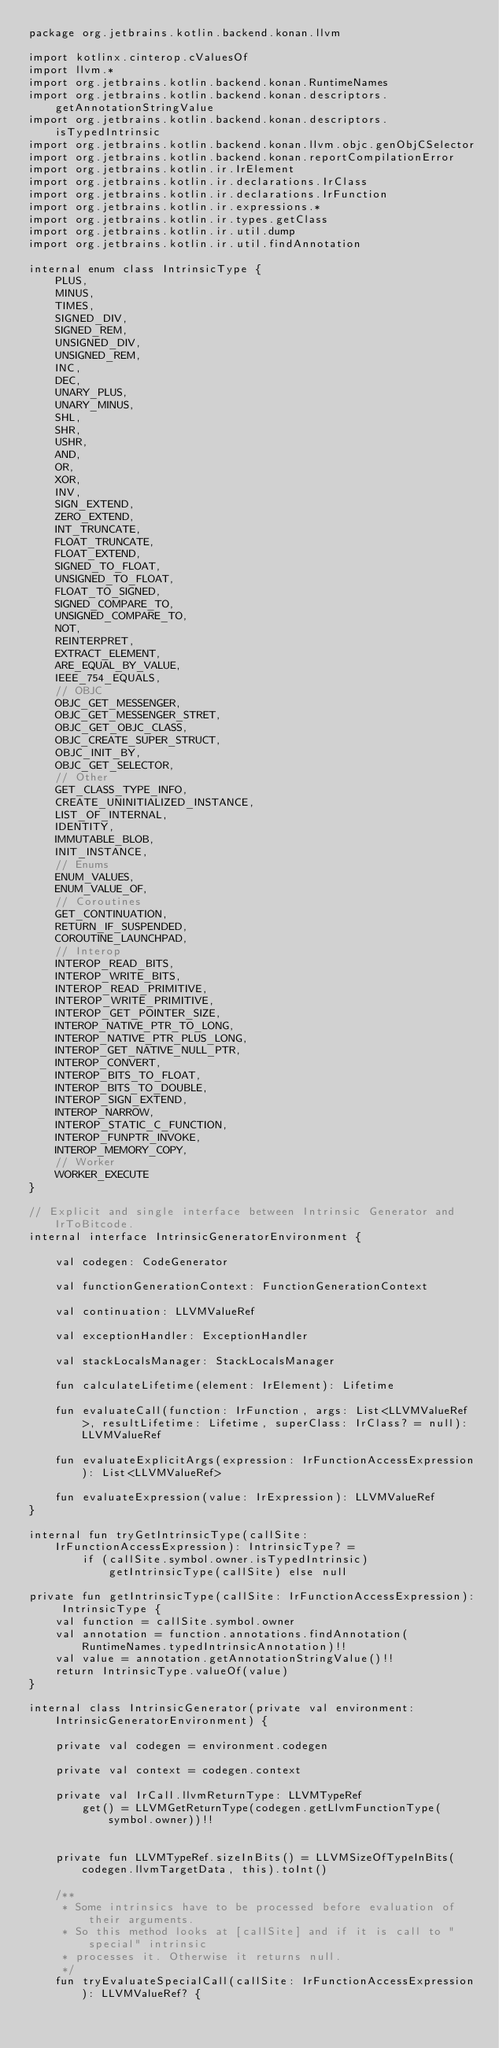Convert code to text. <code><loc_0><loc_0><loc_500><loc_500><_Kotlin_>package org.jetbrains.kotlin.backend.konan.llvm

import kotlinx.cinterop.cValuesOf
import llvm.*
import org.jetbrains.kotlin.backend.konan.RuntimeNames
import org.jetbrains.kotlin.backend.konan.descriptors.getAnnotationStringValue
import org.jetbrains.kotlin.backend.konan.descriptors.isTypedIntrinsic
import org.jetbrains.kotlin.backend.konan.llvm.objc.genObjCSelector
import org.jetbrains.kotlin.backend.konan.reportCompilationError
import org.jetbrains.kotlin.ir.IrElement
import org.jetbrains.kotlin.ir.declarations.IrClass
import org.jetbrains.kotlin.ir.declarations.IrFunction
import org.jetbrains.kotlin.ir.expressions.*
import org.jetbrains.kotlin.ir.types.getClass
import org.jetbrains.kotlin.ir.util.dump
import org.jetbrains.kotlin.ir.util.findAnnotation

internal enum class IntrinsicType {
    PLUS,
    MINUS,
    TIMES,
    SIGNED_DIV,
    SIGNED_REM,
    UNSIGNED_DIV,
    UNSIGNED_REM,
    INC,
    DEC,
    UNARY_PLUS,
    UNARY_MINUS,
    SHL,
    SHR,
    USHR,
    AND,
    OR,
    XOR,
    INV,
    SIGN_EXTEND,
    ZERO_EXTEND,
    INT_TRUNCATE,
    FLOAT_TRUNCATE,
    FLOAT_EXTEND,
    SIGNED_TO_FLOAT,
    UNSIGNED_TO_FLOAT,
    FLOAT_TO_SIGNED,
    SIGNED_COMPARE_TO,
    UNSIGNED_COMPARE_TO,
    NOT,
    REINTERPRET,
    EXTRACT_ELEMENT,
    ARE_EQUAL_BY_VALUE,
    IEEE_754_EQUALS,
    // OBJC
    OBJC_GET_MESSENGER,
    OBJC_GET_MESSENGER_STRET,
    OBJC_GET_OBJC_CLASS,
    OBJC_CREATE_SUPER_STRUCT,
    OBJC_INIT_BY,
    OBJC_GET_SELECTOR,
    // Other
    GET_CLASS_TYPE_INFO,
    CREATE_UNINITIALIZED_INSTANCE,
    LIST_OF_INTERNAL,
    IDENTITY,
    IMMUTABLE_BLOB,
    INIT_INSTANCE,
    // Enums
    ENUM_VALUES,
    ENUM_VALUE_OF,
    // Coroutines
    GET_CONTINUATION,
    RETURN_IF_SUSPENDED,
    COROUTINE_LAUNCHPAD,
    // Interop
    INTEROP_READ_BITS,
    INTEROP_WRITE_BITS,
    INTEROP_READ_PRIMITIVE,
    INTEROP_WRITE_PRIMITIVE,
    INTEROP_GET_POINTER_SIZE,
    INTEROP_NATIVE_PTR_TO_LONG,
    INTEROP_NATIVE_PTR_PLUS_LONG,
    INTEROP_GET_NATIVE_NULL_PTR,
    INTEROP_CONVERT,
    INTEROP_BITS_TO_FLOAT,
    INTEROP_BITS_TO_DOUBLE,
    INTEROP_SIGN_EXTEND,
    INTEROP_NARROW,
    INTEROP_STATIC_C_FUNCTION,
    INTEROP_FUNPTR_INVOKE,
    INTEROP_MEMORY_COPY,
    // Worker
    WORKER_EXECUTE
}

// Explicit and single interface between Intrinsic Generator and IrToBitcode.
internal interface IntrinsicGeneratorEnvironment {

    val codegen: CodeGenerator

    val functionGenerationContext: FunctionGenerationContext

    val continuation: LLVMValueRef

    val exceptionHandler: ExceptionHandler

    val stackLocalsManager: StackLocalsManager

    fun calculateLifetime(element: IrElement): Lifetime

    fun evaluateCall(function: IrFunction, args: List<LLVMValueRef>, resultLifetime: Lifetime, superClass: IrClass? = null): LLVMValueRef

    fun evaluateExplicitArgs(expression: IrFunctionAccessExpression): List<LLVMValueRef>

    fun evaluateExpression(value: IrExpression): LLVMValueRef
}

internal fun tryGetIntrinsicType(callSite: IrFunctionAccessExpression): IntrinsicType? =
        if (callSite.symbol.owner.isTypedIntrinsic) getIntrinsicType(callSite) else null

private fun getIntrinsicType(callSite: IrFunctionAccessExpression): IntrinsicType {
    val function = callSite.symbol.owner
    val annotation = function.annotations.findAnnotation(RuntimeNames.typedIntrinsicAnnotation)!!
    val value = annotation.getAnnotationStringValue()!!
    return IntrinsicType.valueOf(value)
}

internal class IntrinsicGenerator(private val environment: IntrinsicGeneratorEnvironment) {

    private val codegen = environment.codegen

    private val context = codegen.context

    private val IrCall.llvmReturnType: LLVMTypeRef
        get() = LLVMGetReturnType(codegen.getLlvmFunctionType(symbol.owner))!!


    private fun LLVMTypeRef.sizeInBits() = LLVMSizeOfTypeInBits(codegen.llvmTargetData, this).toInt()

    /**
     * Some intrinsics have to be processed before evaluation of their arguments.
     * So this method looks at [callSite] and if it is call to "special" intrinsic
     * processes it. Otherwise it returns null.
     */
    fun tryEvaluateSpecialCall(callSite: IrFunctionAccessExpression): LLVMValueRef? {</code> 